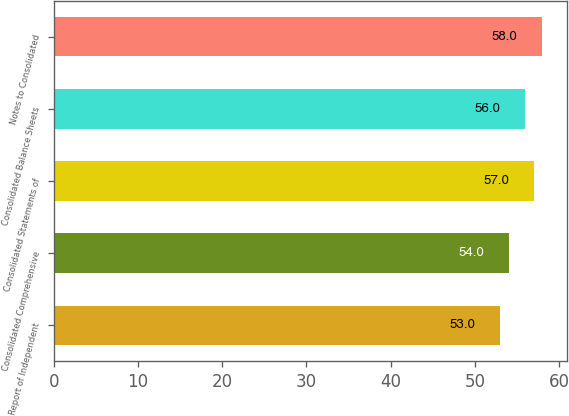Convert chart to OTSL. <chart><loc_0><loc_0><loc_500><loc_500><bar_chart><fcel>Report of Independent<fcel>Consolidated Comprehensive<fcel>Consolidated Statements of<fcel>Consolidated Balance Sheets<fcel>Notes to Consolidated<nl><fcel>53<fcel>54<fcel>57<fcel>56<fcel>58<nl></chart> 